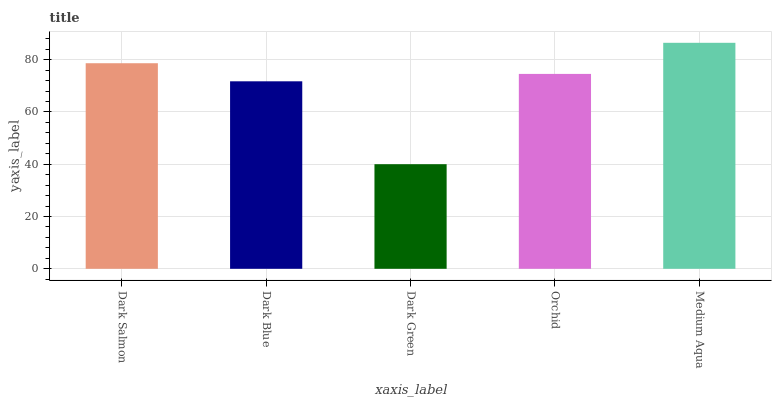Is Dark Green the minimum?
Answer yes or no. Yes. Is Medium Aqua the maximum?
Answer yes or no. Yes. Is Dark Blue the minimum?
Answer yes or no. No. Is Dark Blue the maximum?
Answer yes or no. No. Is Dark Salmon greater than Dark Blue?
Answer yes or no. Yes. Is Dark Blue less than Dark Salmon?
Answer yes or no. Yes. Is Dark Blue greater than Dark Salmon?
Answer yes or no. No. Is Dark Salmon less than Dark Blue?
Answer yes or no. No. Is Orchid the high median?
Answer yes or no. Yes. Is Orchid the low median?
Answer yes or no. Yes. Is Dark Blue the high median?
Answer yes or no. No. Is Dark Salmon the low median?
Answer yes or no. No. 